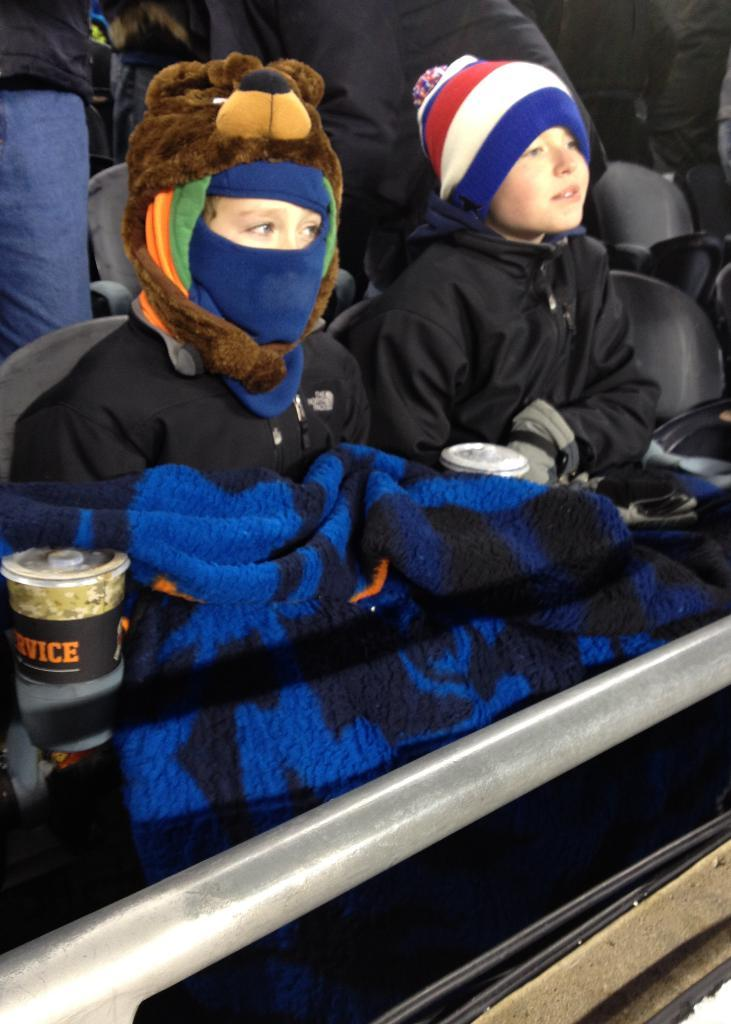What are the people in the image doing? The people in the image are sitting on chairs. What else can be seen in the image besides the people sitting on chairs? There are food items present in the image. What type of territory is being claimed by the men in the image? There are no men present in the image, and no territory is being claimed. 